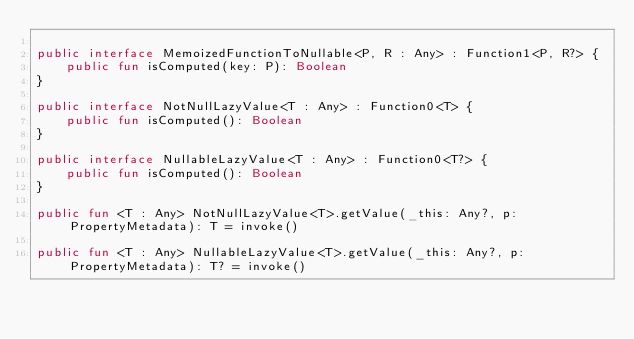Convert code to text. <code><loc_0><loc_0><loc_500><loc_500><_Kotlin_>
public interface MemoizedFunctionToNullable<P, R : Any> : Function1<P, R?> {
    public fun isComputed(key: P): Boolean
}

public interface NotNullLazyValue<T : Any> : Function0<T> {
    public fun isComputed(): Boolean
}

public interface NullableLazyValue<T : Any> : Function0<T?> {
    public fun isComputed(): Boolean
}

public fun <T : Any> NotNullLazyValue<T>.getValue(_this: Any?, p: PropertyMetadata): T = invoke()

public fun <T : Any> NullableLazyValue<T>.getValue(_this: Any?, p: PropertyMetadata): T? = invoke()
</code> 